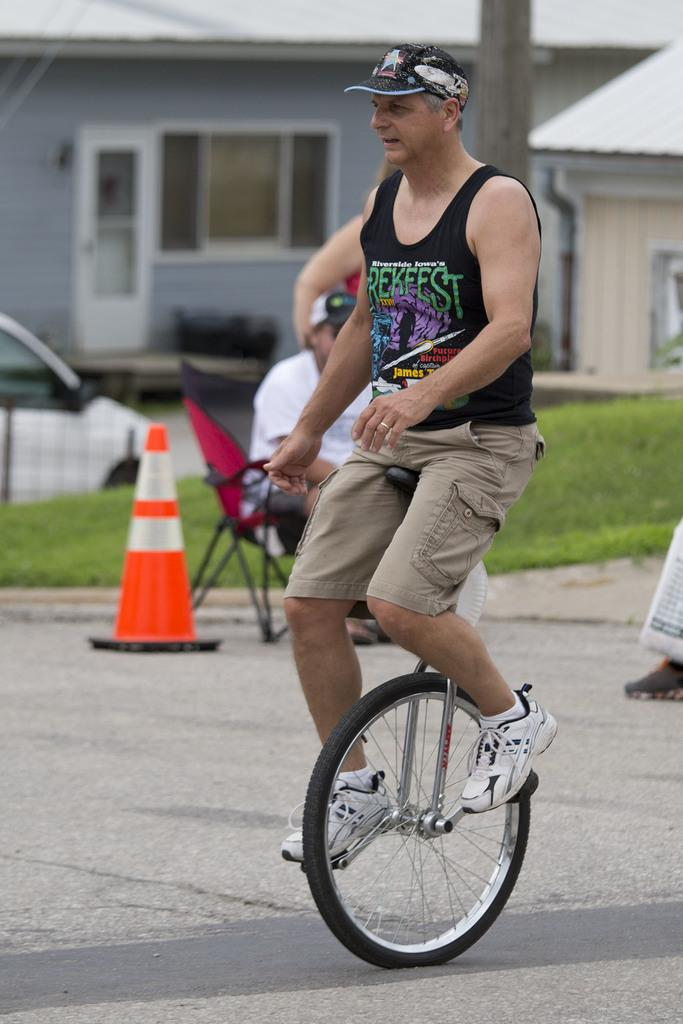What is the man in the image doing? There is a man riding a bicycle in the image. What is the other man in the image doing? There is a man sitting on a chair in the image. What can be seen in the background of the image? There is a building visible in the image. What type of vegetation is present in the image? There is grass in the image. How does the bucket contribute to the growth of the grass in the image? There is no bucket present in the image, so it cannot contribute to the growth of the grass. 